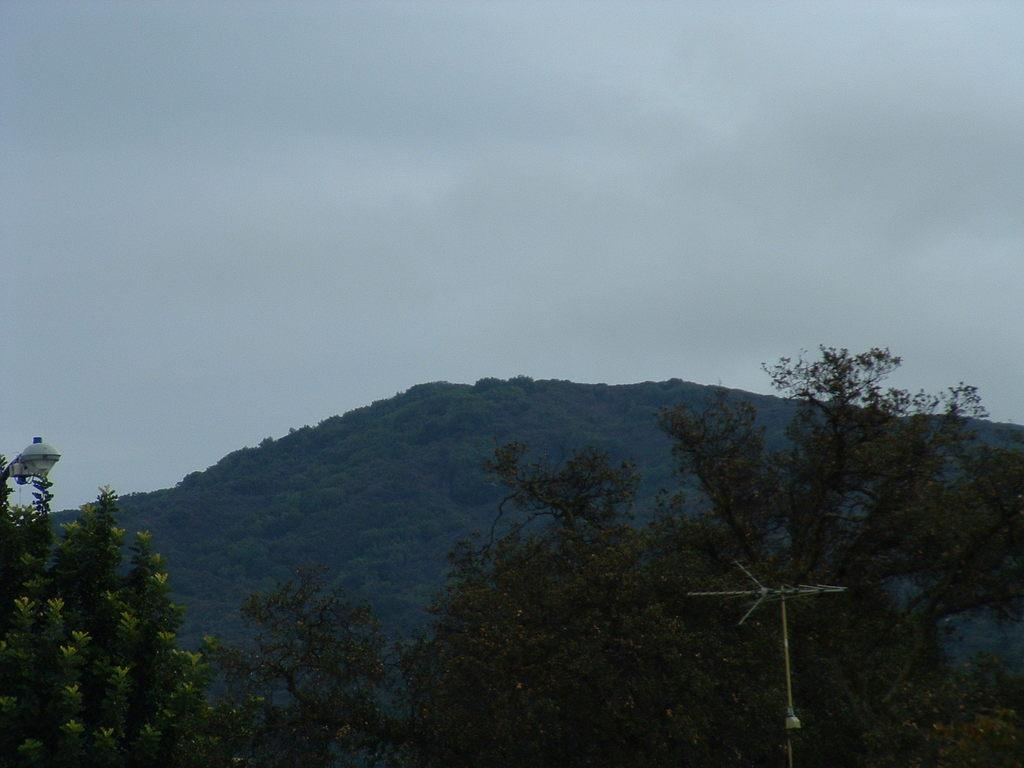What type of vegetation is at the bottom of the image? There are trees at the bottom of the image. What geographical feature is in the middle of the image? There is a hill in the middle of the image. What is visible at the top of the image? The sky is visible at the top of the image. How would you describe the sky in the image? The sky appears to be cloudy. What type of jewel is hanging from the trees in the image? There are no jewels present in the image; it features trees, a hill, and a cloudy sky. Can you read the letter that is lying on the hill in the image? There is no letter present in the image; it only features trees, a hill, and a cloudy sky. 